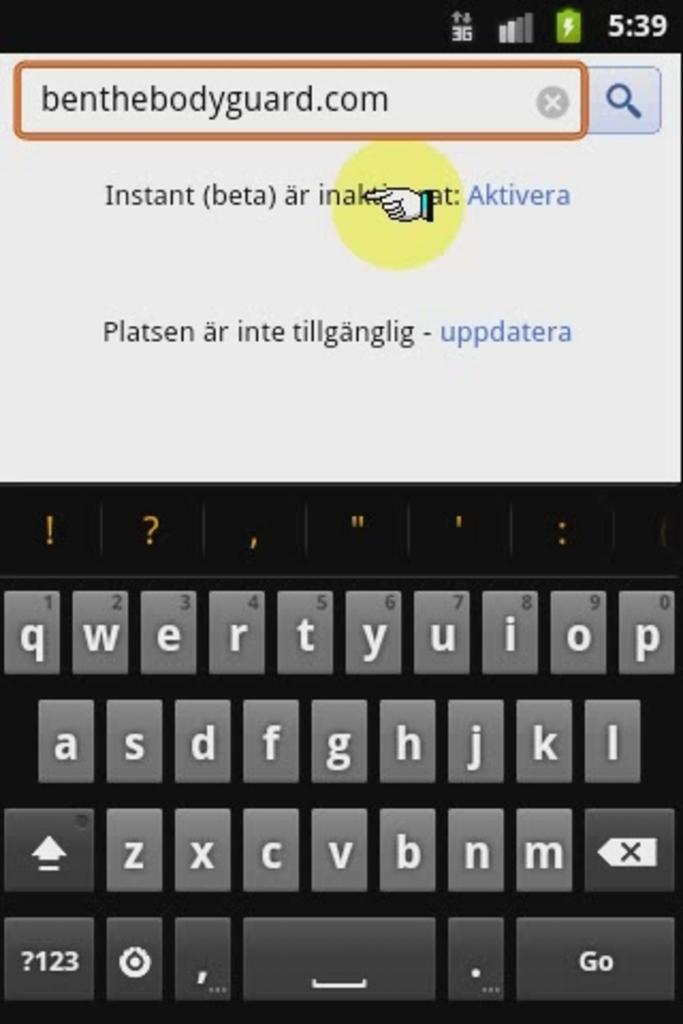<image>
Present a compact description of the photo's key features. The display of a smartphone where a user had typed in the url benthebodyguard.com 